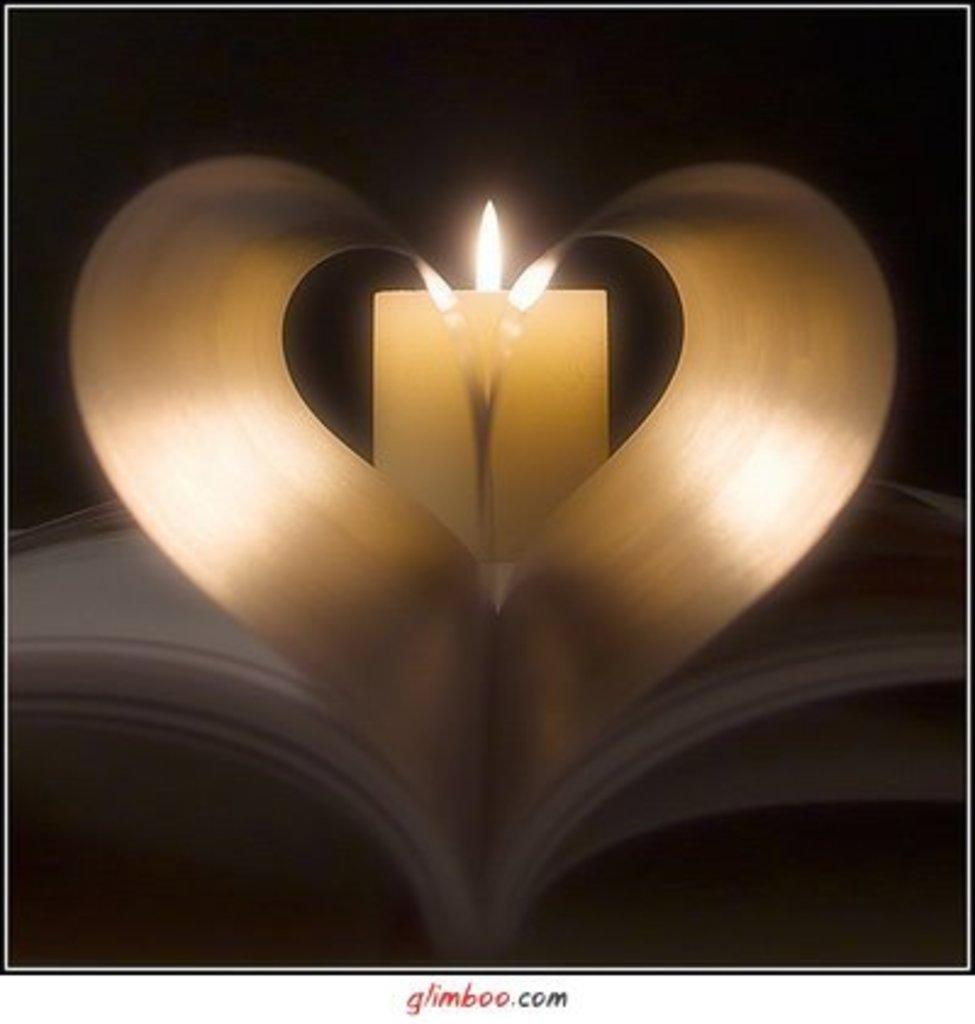What object can be seen in the image related to reading or learning? There is a book in the image. What source of light is present in the image? There is a candlelight in the image. How would you describe the lighting conditions in the image? The background of the image is dark. Is there any text visible in the image? Yes, there is text written at the bottom of the image. How many hands are holding the book in the image? There are no hands visible in the image, as it only shows a book and a candlelight. 